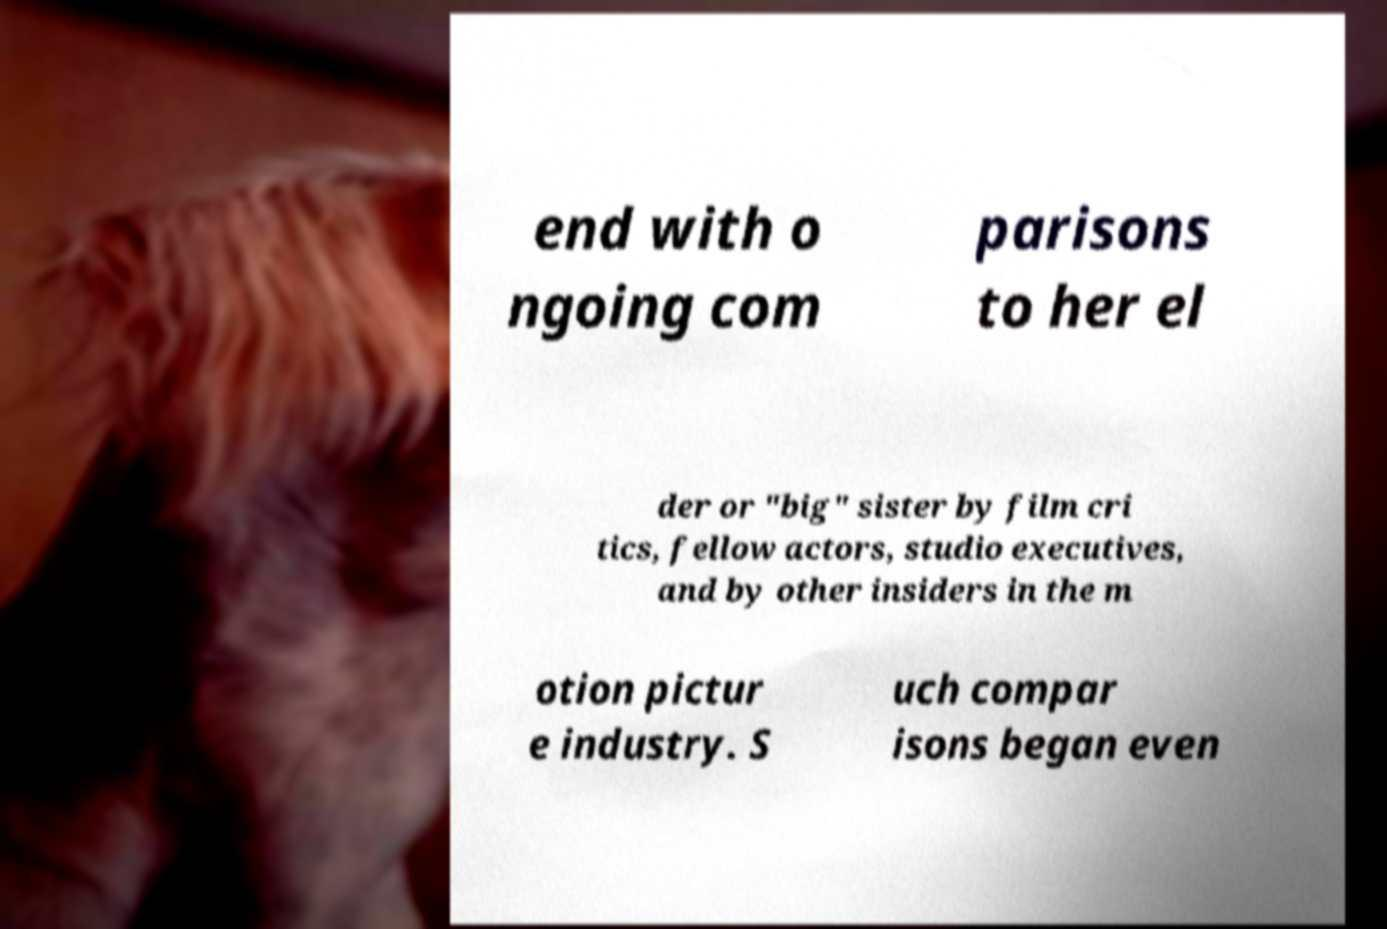Please read and relay the text visible in this image. What does it say? end with o ngoing com parisons to her el der or "big" sister by film cri tics, fellow actors, studio executives, and by other insiders in the m otion pictur e industry. S uch compar isons began even 